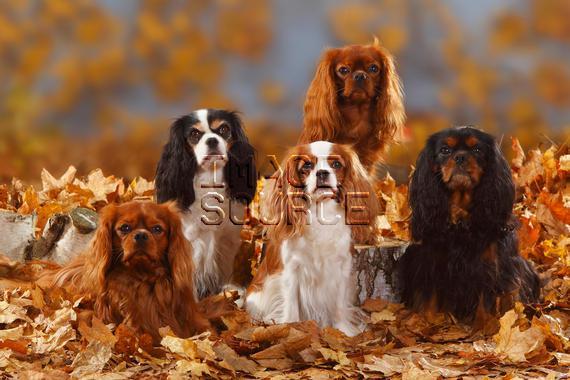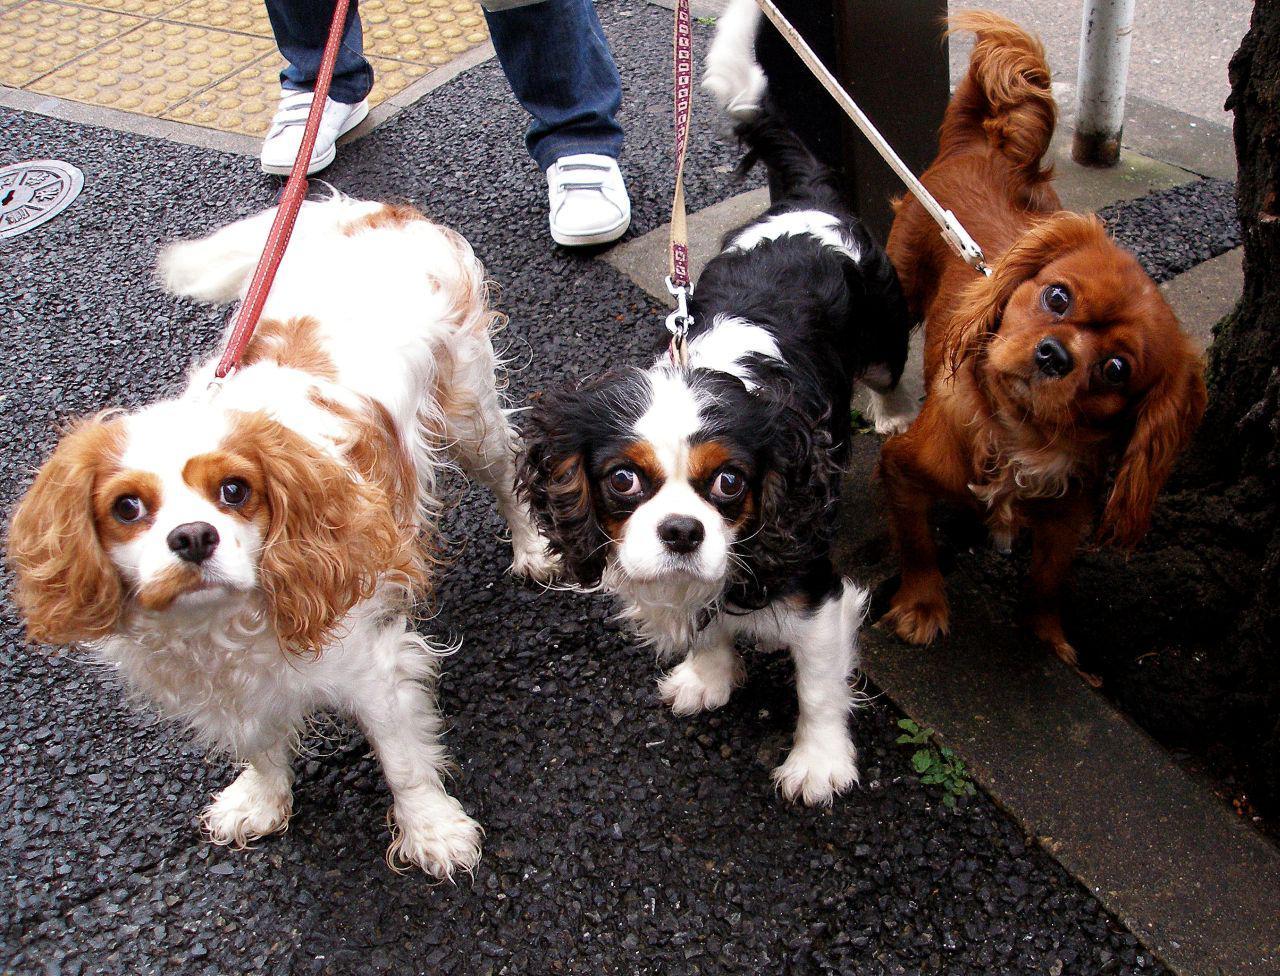The first image is the image on the left, the second image is the image on the right. For the images shown, is this caption "Two puppies are being held by human hands." true? Answer yes or no. No. The first image is the image on the left, the second image is the image on the right. Considering the images on both sides, is "One image has a human body part as well as dogs." valid? Answer yes or no. Yes. 